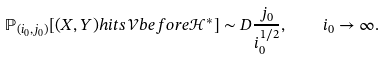<formula> <loc_0><loc_0><loc_500><loc_500>\mathbb { P } _ { ( i _ { 0 } , j _ { 0 } ) } [ ( X , Y ) h i t s \mathcal { V } b e f o r e \mathcal { H } ^ { * } ] \sim D \frac { j _ { 0 } } { i _ { 0 } ^ { 1 / 2 } } , \quad i _ { 0 } \to \infty .</formula> 